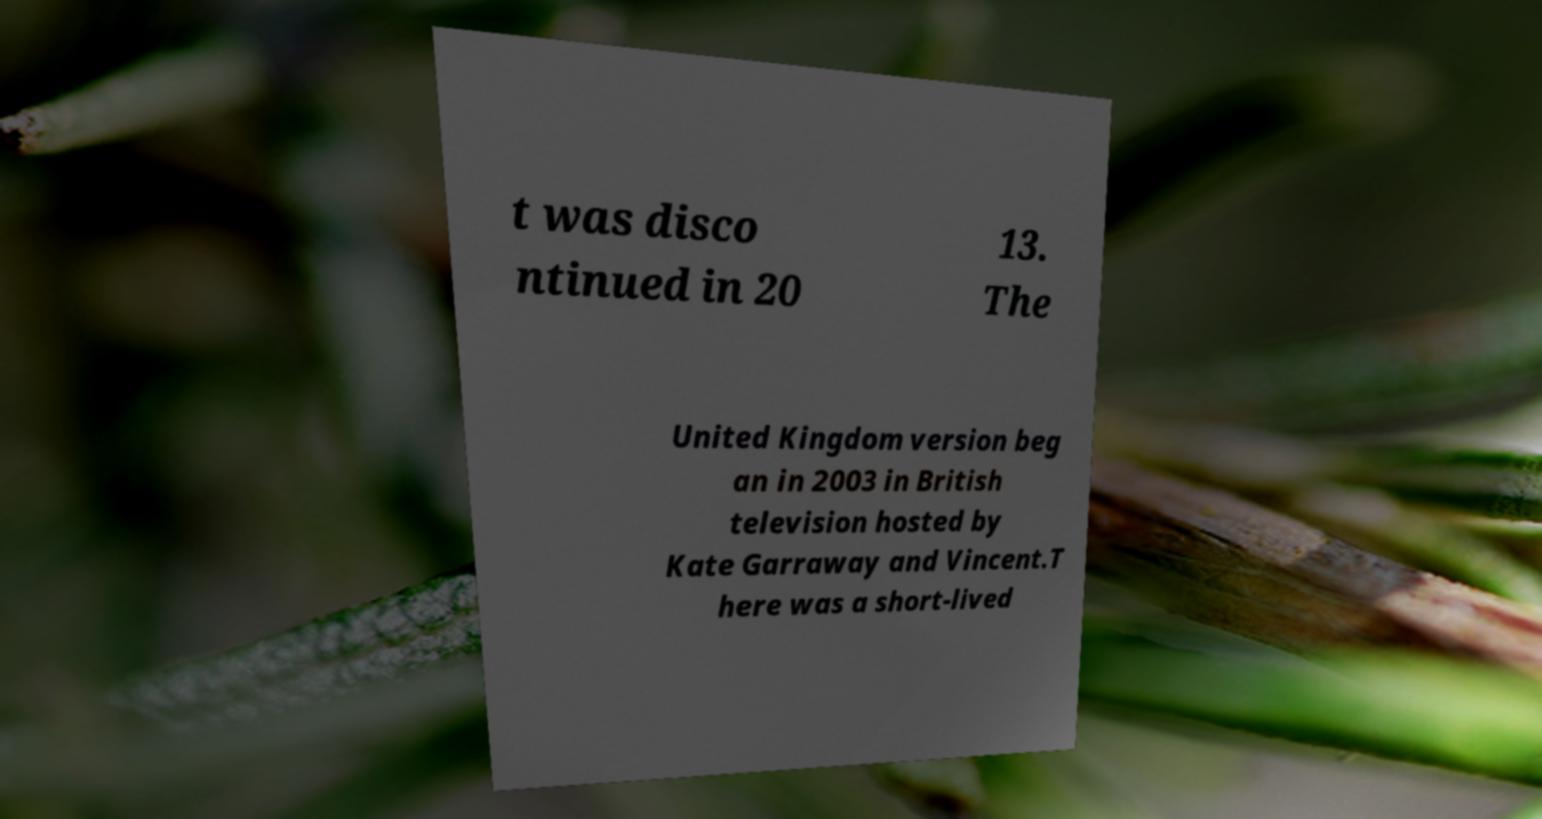For documentation purposes, I need the text within this image transcribed. Could you provide that? t was disco ntinued in 20 13. The United Kingdom version beg an in 2003 in British television hosted by Kate Garraway and Vincent.T here was a short-lived 